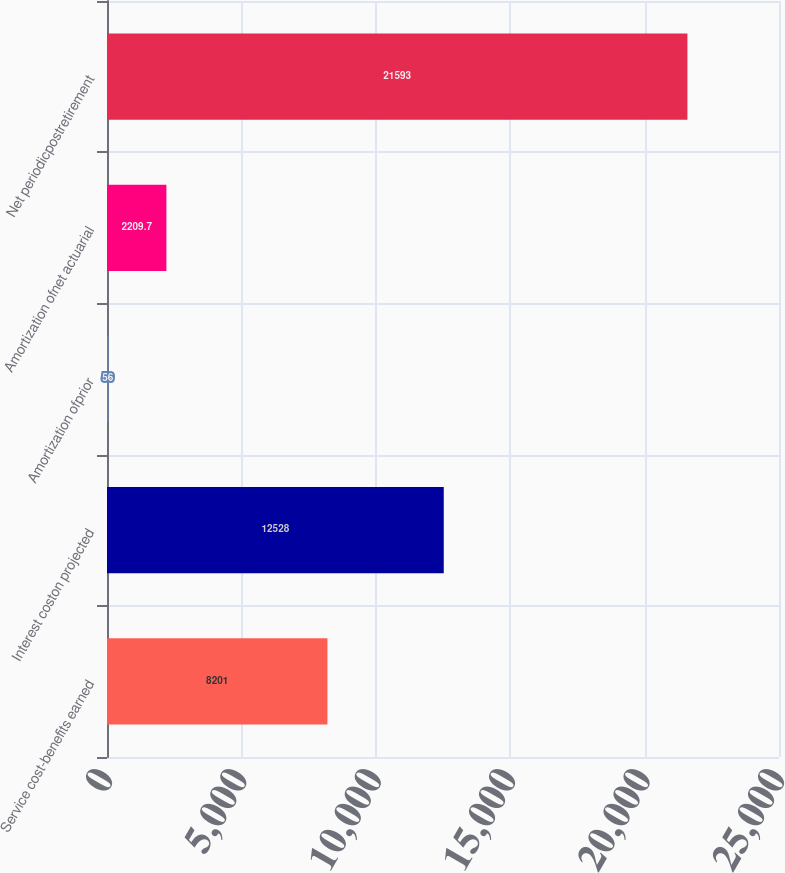Convert chart to OTSL. <chart><loc_0><loc_0><loc_500><loc_500><bar_chart><fcel>Service cost-benefits earned<fcel>Interest coston projected<fcel>Amortization ofprior<fcel>Amortization ofnet actuarial<fcel>Net periodicpostretirement<nl><fcel>8201<fcel>12528<fcel>56<fcel>2209.7<fcel>21593<nl></chart> 